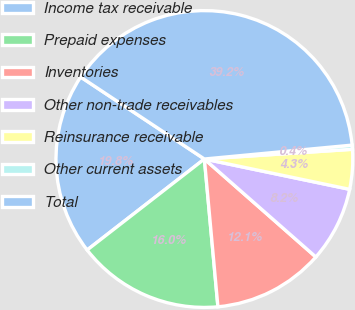Convert chart. <chart><loc_0><loc_0><loc_500><loc_500><pie_chart><fcel>Income tax receivable<fcel>Prepaid expenses<fcel>Inventories<fcel>Other non-trade receivables<fcel>Reinsurance receivable<fcel>Other current assets<fcel>Total<nl><fcel>19.82%<fcel>15.95%<fcel>12.07%<fcel>8.2%<fcel>4.32%<fcel>0.45%<fcel>39.19%<nl></chart> 